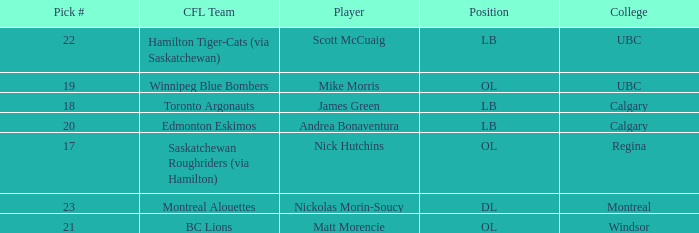What position is the player who went to Regina?  OL. 